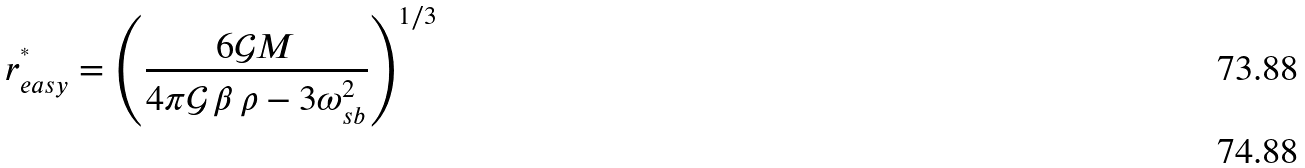Convert formula to latex. <formula><loc_0><loc_0><loc_500><loc_500>r ^ { ^ { * } } _ { e a s y } = \left ( \frac { 6 \mathcal { G } M } { 4 \pi \mathcal { G } \, \beta \, \rho - 3 \omega _ { s b } ^ { 2 } } \right ) ^ { 1 / 3 } \\</formula> 